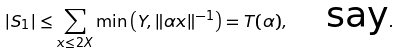Convert formula to latex. <formula><loc_0><loc_0><loc_500><loc_500>| S _ { 1 } | \leq \sum _ { x \leq 2 X } \min \left ( Y , \| \alpha x \| ^ { - 1 } \right ) = T ( \alpha ) , \quad \text {say} .</formula> 